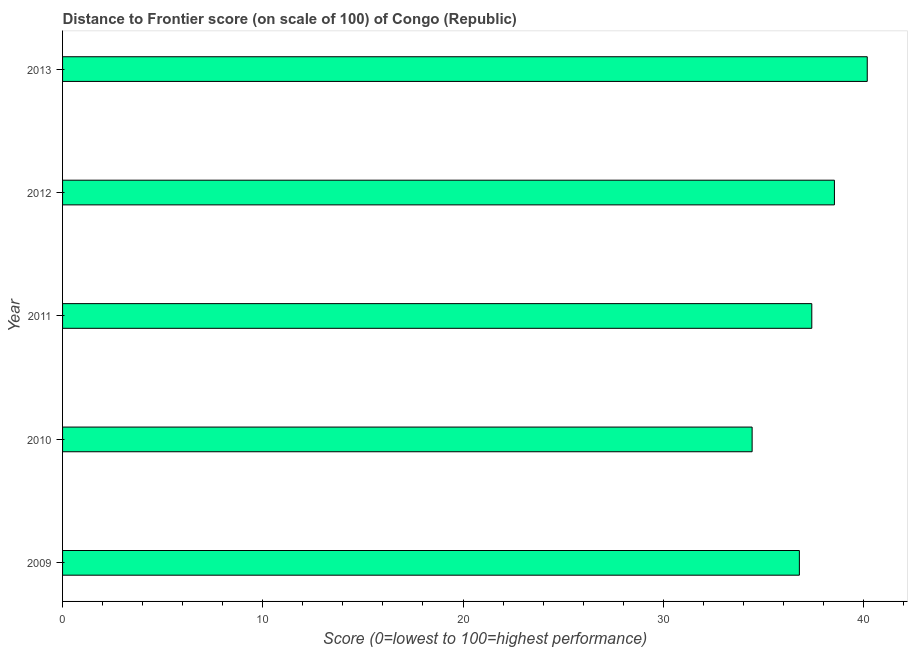Does the graph contain any zero values?
Your answer should be very brief. No. What is the title of the graph?
Your response must be concise. Distance to Frontier score (on scale of 100) of Congo (Republic). What is the label or title of the X-axis?
Your answer should be compact. Score (0=lowest to 100=highest performance). What is the distance to frontier score in 2012?
Provide a short and direct response. 38.55. Across all years, what is the maximum distance to frontier score?
Make the answer very short. 40.19. Across all years, what is the minimum distance to frontier score?
Provide a succinct answer. 34.44. In which year was the distance to frontier score maximum?
Give a very brief answer. 2013. What is the sum of the distance to frontier score?
Offer a very short reply. 187.4. What is the difference between the distance to frontier score in 2009 and 2010?
Your answer should be compact. 2.36. What is the average distance to frontier score per year?
Provide a succinct answer. 37.48. What is the median distance to frontier score?
Offer a very short reply. 37.42. Do a majority of the years between 2009 and 2013 (inclusive) have distance to frontier score greater than 16 ?
Provide a succinct answer. Yes. What is the ratio of the distance to frontier score in 2010 to that in 2013?
Keep it short and to the point. 0.86. Is the difference between the distance to frontier score in 2009 and 2010 greater than the difference between any two years?
Provide a succinct answer. No. What is the difference between the highest and the second highest distance to frontier score?
Your answer should be very brief. 1.64. Is the sum of the distance to frontier score in 2010 and 2013 greater than the maximum distance to frontier score across all years?
Offer a very short reply. Yes. What is the difference between the highest and the lowest distance to frontier score?
Offer a terse response. 5.75. How many bars are there?
Offer a very short reply. 5. Are all the bars in the graph horizontal?
Make the answer very short. Yes. How many years are there in the graph?
Provide a short and direct response. 5. Are the values on the major ticks of X-axis written in scientific E-notation?
Ensure brevity in your answer.  No. What is the Score (0=lowest to 100=highest performance) in 2009?
Your response must be concise. 36.8. What is the Score (0=lowest to 100=highest performance) in 2010?
Ensure brevity in your answer.  34.44. What is the Score (0=lowest to 100=highest performance) in 2011?
Offer a terse response. 37.42. What is the Score (0=lowest to 100=highest performance) in 2012?
Give a very brief answer. 38.55. What is the Score (0=lowest to 100=highest performance) in 2013?
Make the answer very short. 40.19. What is the difference between the Score (0=lowest to 100=highest performance) in 2009 and 2010?
Your response must be concise. 2.36. What is the difference between the Score (0=lowest to 100=highest performance) in 2009 and 2011?
Offer a very short reply. -0.62. What is the difference between the Score (0=lowest to 100=highest performance) in 2009 and 2012?
Provide a short and direct response. -1.75. What is the difference between the Score (0=lowest to 100=highest performance) in 2009 and 2013?
Make the answer very short. -3.39. What is the difference between the Score (0=lowest to 100=highest performance) in 2010 and 2011?
Keep it short and to the point. -2.98. What is the difference between the Score (0=lowest to 100=highest performance) in 2010 and 2012?
Ensure brevity in your answer.  -4.11. What is the difference between the Score (0=lowest to 100=highest performance) in 2010 and 2013?
Give a very brief answer. -5.75. What is the difference between the Score (0=lowest to 100=highest performance) in 2011 and 2012?
Your answer should be compact. -1.13. What is the difference between the Score (0=lowest to 100=highest performance) in 2011 and 2013?
Offer a terse response. -2.77. What is the difference between the Score (0=lowest to 100=highest performance) in 2012 and 2013?
Your response must be concise. -1.64. What is the ratio of the Score (0=lowest to 100=highest performance) in 2009 to that in 2010?
Your answer should be compact. 1.07. What is the ratio of the Score (0=lowest to 100=highest performance) in 2009 to that in 2012?
Your answer should be compact. 0.95. What is the ratio of the Score (0=lowest to 100=highest performance) in 2009 to that in 2013?
Provide a short and direct response. 0.92. What is the ratio of the Score (0=lowest to 100=highest performance) in 2010 to that in 2011?
Give a very brief answer. 0.92. What is the ratio of the Score (0=lowest to 100=highest performance) in 2010 to that in 2012?
Offer a terse response. 0.89. What is the ratio of the Score (0=lowest to 100=highest performance) in 2010 to that in 2013?
Give a very brief answer. 0.86. What is the ratio of the Score (0=lowest to 100=highest performance) in 2012 to that in 2013?
Keep it short and to the point. 0.96. 